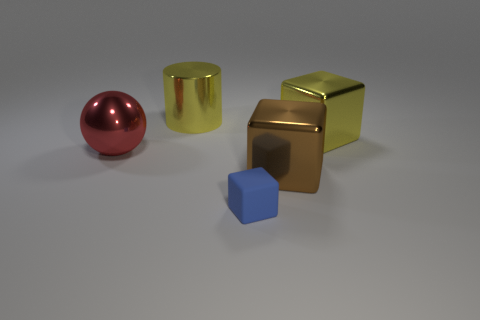Are there any other things that have the same material as the blue object?
Offer a very short reply. No. There is a object that is on the left side of the brown metal cube and to the right of the large yellow metallic cylinder; what shape is it?
Provide a short and direct response. Cube. The brown object that is the same material as the large ball is what shape?
Your answer should be compact. Cube. Is there a yellow metal thing?
Ensure brevity in your answer.  Yes. There is a large metallic block that is in front of the large red object; is there a tiny cube behind it?
Your answer should be very brief. No. There is a large yellow thing that is the same shape as the blue rubber thing; what is it made of?
Provide a short and direct response. Metal. Are there more large shiny balls than yellow things?
Give a very brief answer. No. Is the color of the metal cylinder the same as the large shiny cube that is behind the big brown shiny object?
Keep it short and to the point. Yes. The cube that is both in front of the sphere and behind the matte object is what color?
Your answer should be very brief. Brown. How many other objects are there of the same material as the large cylinder?
Keep it short and to the point. 3. 